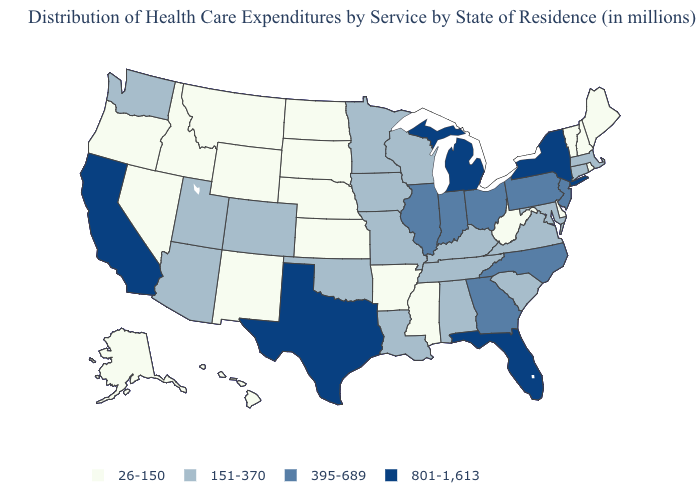Which states have the lowest value in the South?
Be succinct. Arkansas, Delaware, Mississippi, West Virginia. Does the map have missing data?
Keep it brief. No. How many symbols are there in the legend?
Short answer required. 4. Name the states that have a value in the range 395-689?
Concise answer only. Georgia, Illinois, Indiana, New Jersey, North Carolina, Ohio, Pennsylvania. Does the first symbol in the legend represent the smallest category?
Keep it brief. Yes. What is the value of Oregon?
Give a very brief answer. 26-150. Name the states that have a value in the range 801-1,613?
Answer briefly. California, Florida, Michigan, New York, Texas. Name the states that have a value in the range 151-370?
Be succinct. Alabama, Arizona, Colorado, Connecticut, Iowa, Kentucky, Louisiana, Maryland, Massachusetts, Minnesota, Missouri, Oklahoma, South Carolina, Tennessee, Utah, Virginia, Washington, Wisconsin. What is the highest value in states that border Massachusetts?
Short answer required. 801-1,613. What is the value of Rhode Island?
Write a very short answer. 26-150. Among the states that border Arkansas , does Texas have the highest value?
Be succinct. Yes. Name the states that have a value in the range 151-370?
Write a very short answer. Alabama, Arizona, Colorado, Connecticut, Iowa, Kentucky, Louisiana, Maryland, Massachusetts, Minnesota, Missouri, Oklahoma, South Carolina, Tennessee, Utah, Virginia, Washington, Wisconsin. Does Florida have the highest value in the South?
Quick response, please. Yes. Name the states that have a value in the range 26-150?
Keep it brief. Alaska, Arkansas, Delaware, Hawaii, Idaho, Kansas, Maine, Mississippi, Montana, Nebraska, Nevada, New Hampshire, New Mexico, North Dakota, Oregon, Rhode Island, South Dakota, Vermont, West Virginia, Wyoming. Is the legend a continuous bar?
Quick response, please. No. 